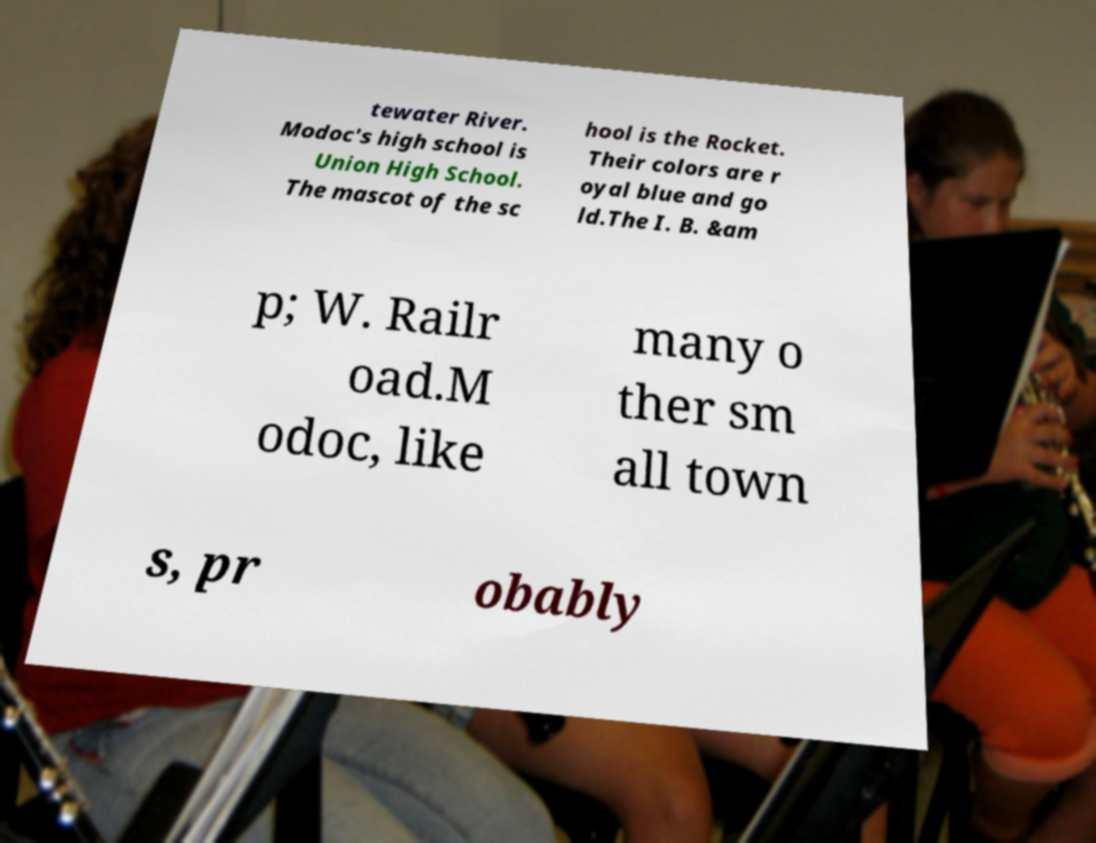Please identify and transcribe the text found in this image. tewater River. Modoc's high school is Union High School. The mascot of the sc hool is the Rocket. Their colors are r oyal blue and go ld.The I. B. &am p; W. Railr oad.M odoc, like many o ther sm all town s, pr obably 